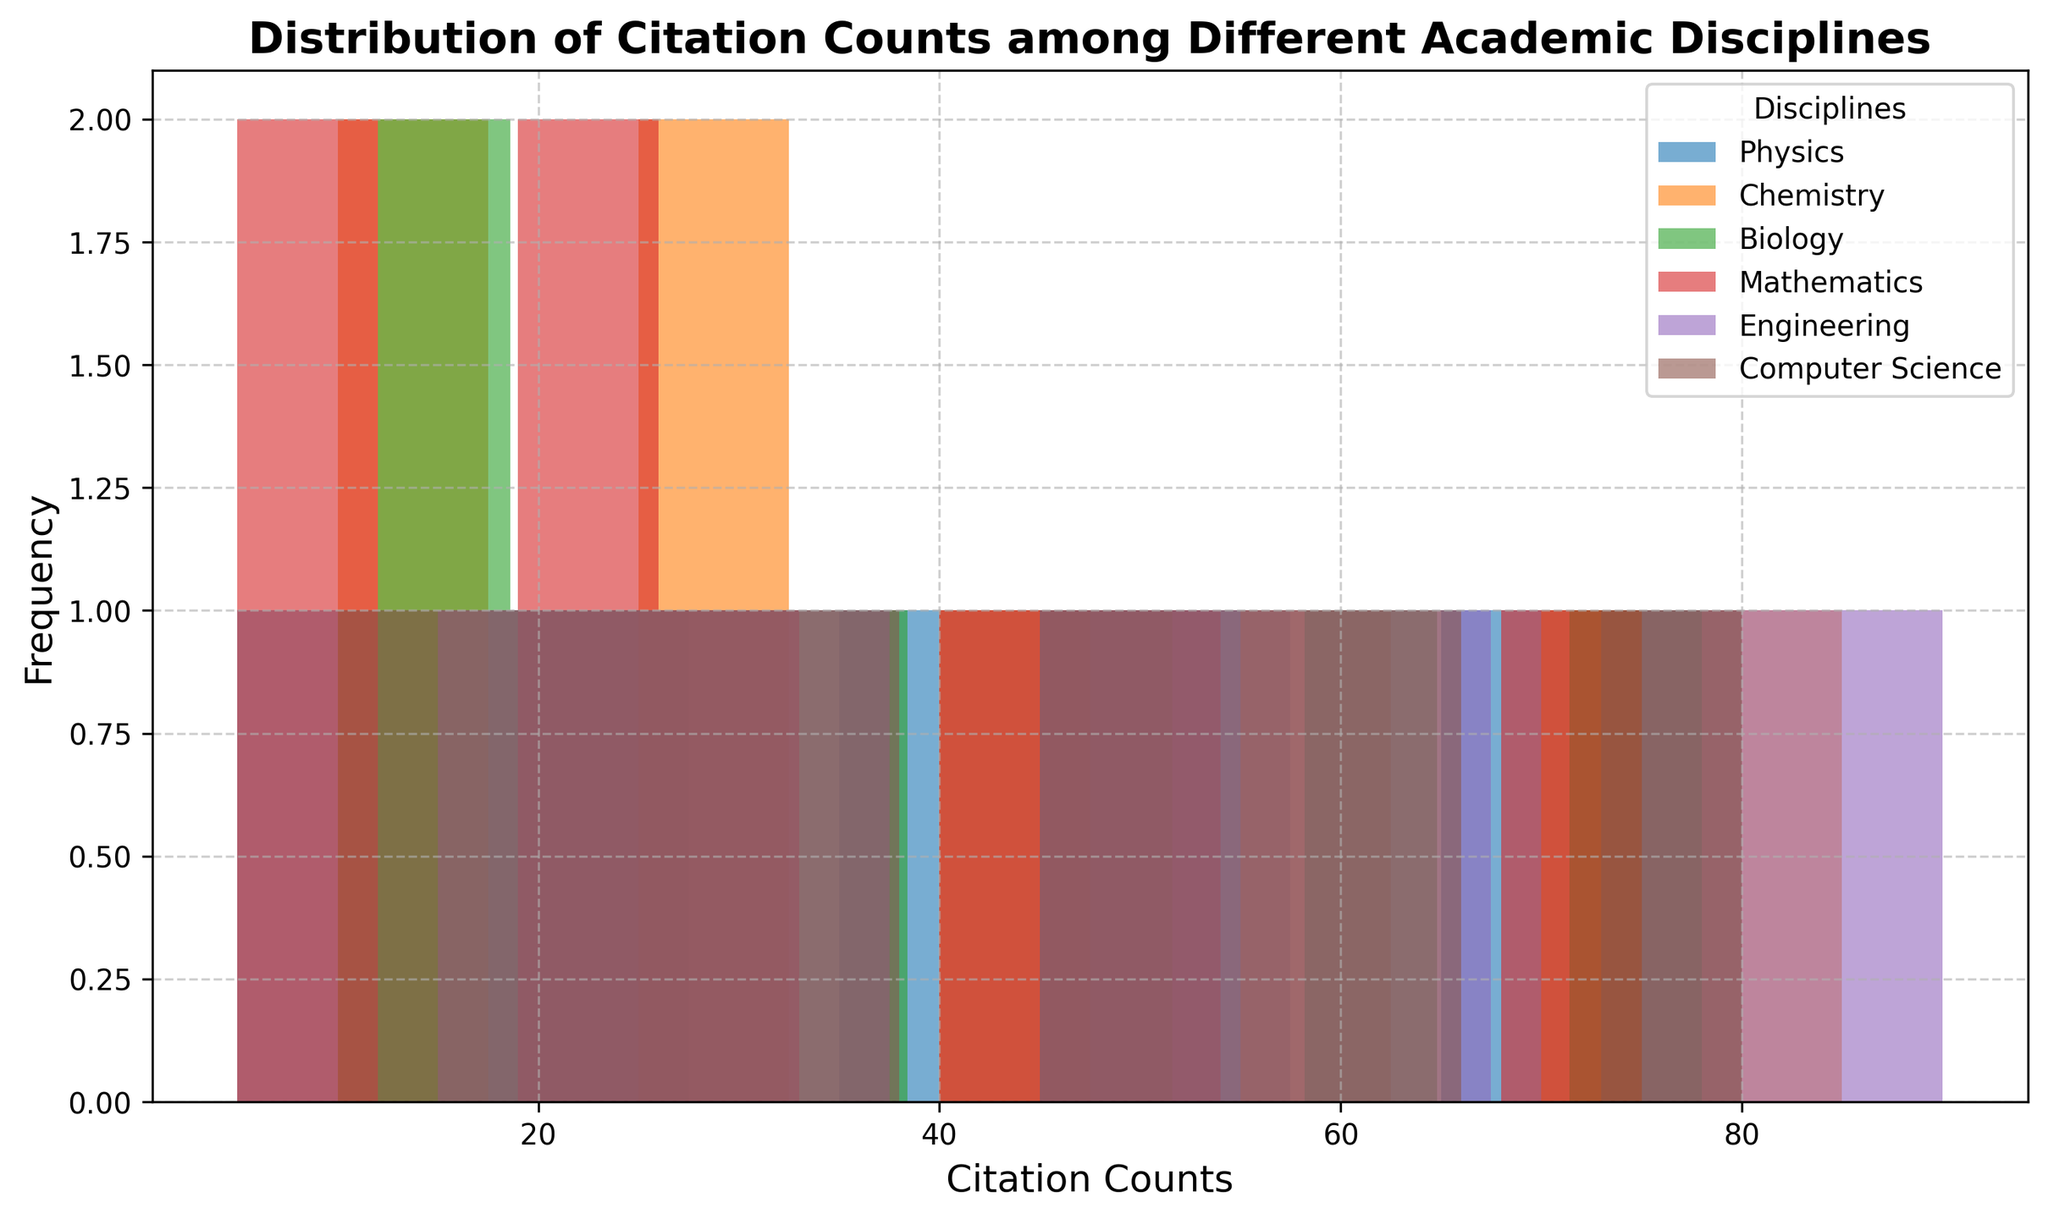What citation range has the highest frequency of citation counts for Physics? Observe the blue histogram bars labeled 'Physics' and identify the range that has the tallest bar.
Answer: 60-70 citations Which discipline shows the widest distribution of citation counts? Compare the spread of citation ranges for all disciplines by looking at the range of x-values each color covers.
Answer: Engineering Among Chemistry and Biology, which discipline has more citations distributed in the 10-20 citations range? Count the frequency of orange (Chemistry) and green (Biology) histogram bars within the 10-20 citations range to compare.
Answer: Chemistry What is the frequency difference in the 50-60 citations range between Engineering and Computer Science? Compare the height of the purple bar (Engineering) and brown bar (Computer Science) in the 50-60 citations range and subtract the smaller height from the larger height.
Answer: Engineering has 1 more Which academic discipline has the highest single frequency of citation counts and what is the range? Identify the tallest single bar across all disciplines and note its corresponding citation range and discipline color.
Answer: Computer Science, 10-20 citations In the 30-40 citations range, which discipline has the lowest frequency? Identify the 30-40 citations range and compare the heights of the bars for each discipline, noting which is the smallest or absent.
Answer: Biology How does the distribution of citation counts in Computer Science compare to Mathematics in the 20-30 citation range? Examine the frequency of brown bars (Computer Science) and red bars (Mathematics) in the 20-30 citation range and compare.
Answer: They are equal What is the combined frequency of citations for Biology and Engineering in the 70-80 citations range? Add the frequencies of green bars (Biology) and purple bars (Engineering) in the 70-80 citations range.
Answer: 1 In the 0-10 citations range, which two disciplines show higher frequencies? Identify the citation counts within the 0-10 range and observe the height of the bars for each discipline, selecting the two highest.
Answer: Physics and Mathematics What is the range where Chemistry has no citation counts? Observe the absence of orange bars (Chemistry) across the x-axis and determine the citation range.
Answer: 60-70 citations 